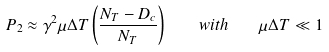<formula> <loc_0><loc_0><loc_500><loc_500>P _ { 2 } \approx \gamma ^ { 2 } \mu \Delta T \left ( \frac { N _ { T } - D _ { c } } { N _ { T } } \right ) \quad w i t h \quad \mu \Delta T \ll 1</formula> 